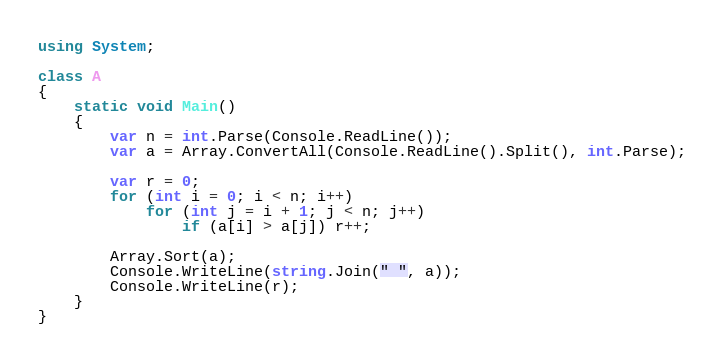<code> <loc_0><loc_0><loc_500><loc_500><_C#_>using System;

class A
{
	static void Main()
	{
		var n = int.Parse(Console.ReadLine());
		var a = Array.ConvertAll(Console.ReadLine().Split(), int.Parse);

		var r = 0;
		for (int i = 0; i < n; i++)
			for (int j = i + 1; j < n; j++)
				if (a[i] > a[j]) r++;

		Array.Sort(a);
		Console.WriteLine(string.Join(" ", a));
		Console.WriteLine(r);
	}
}

</code> 